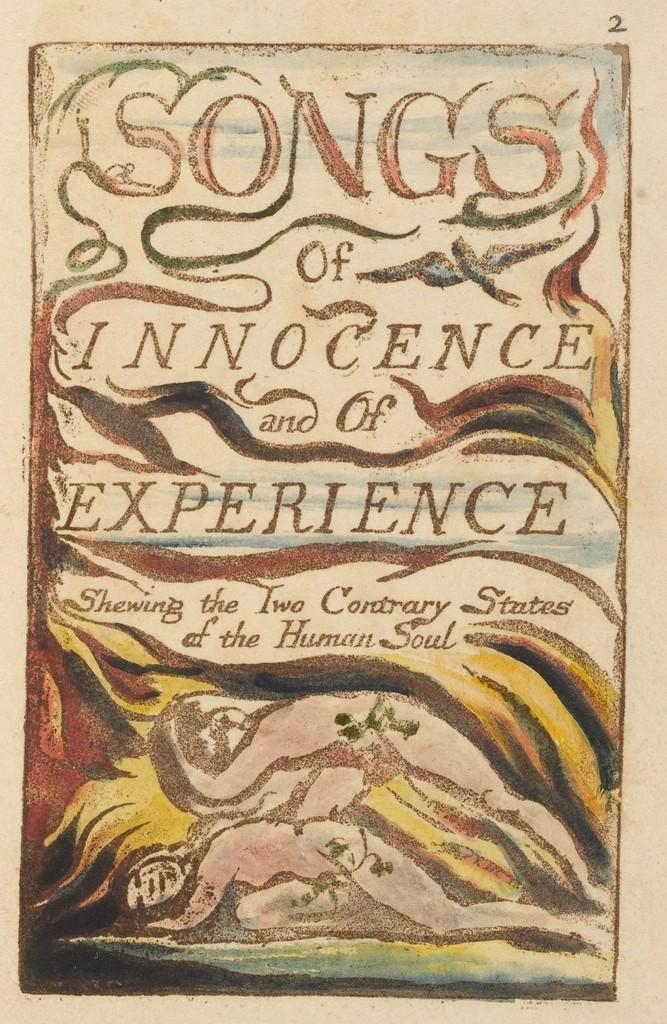<image>
Create a compact narrative representing the image presented. A picture with two naked people sleeping at the bottom labeled Innocence of Experience. 